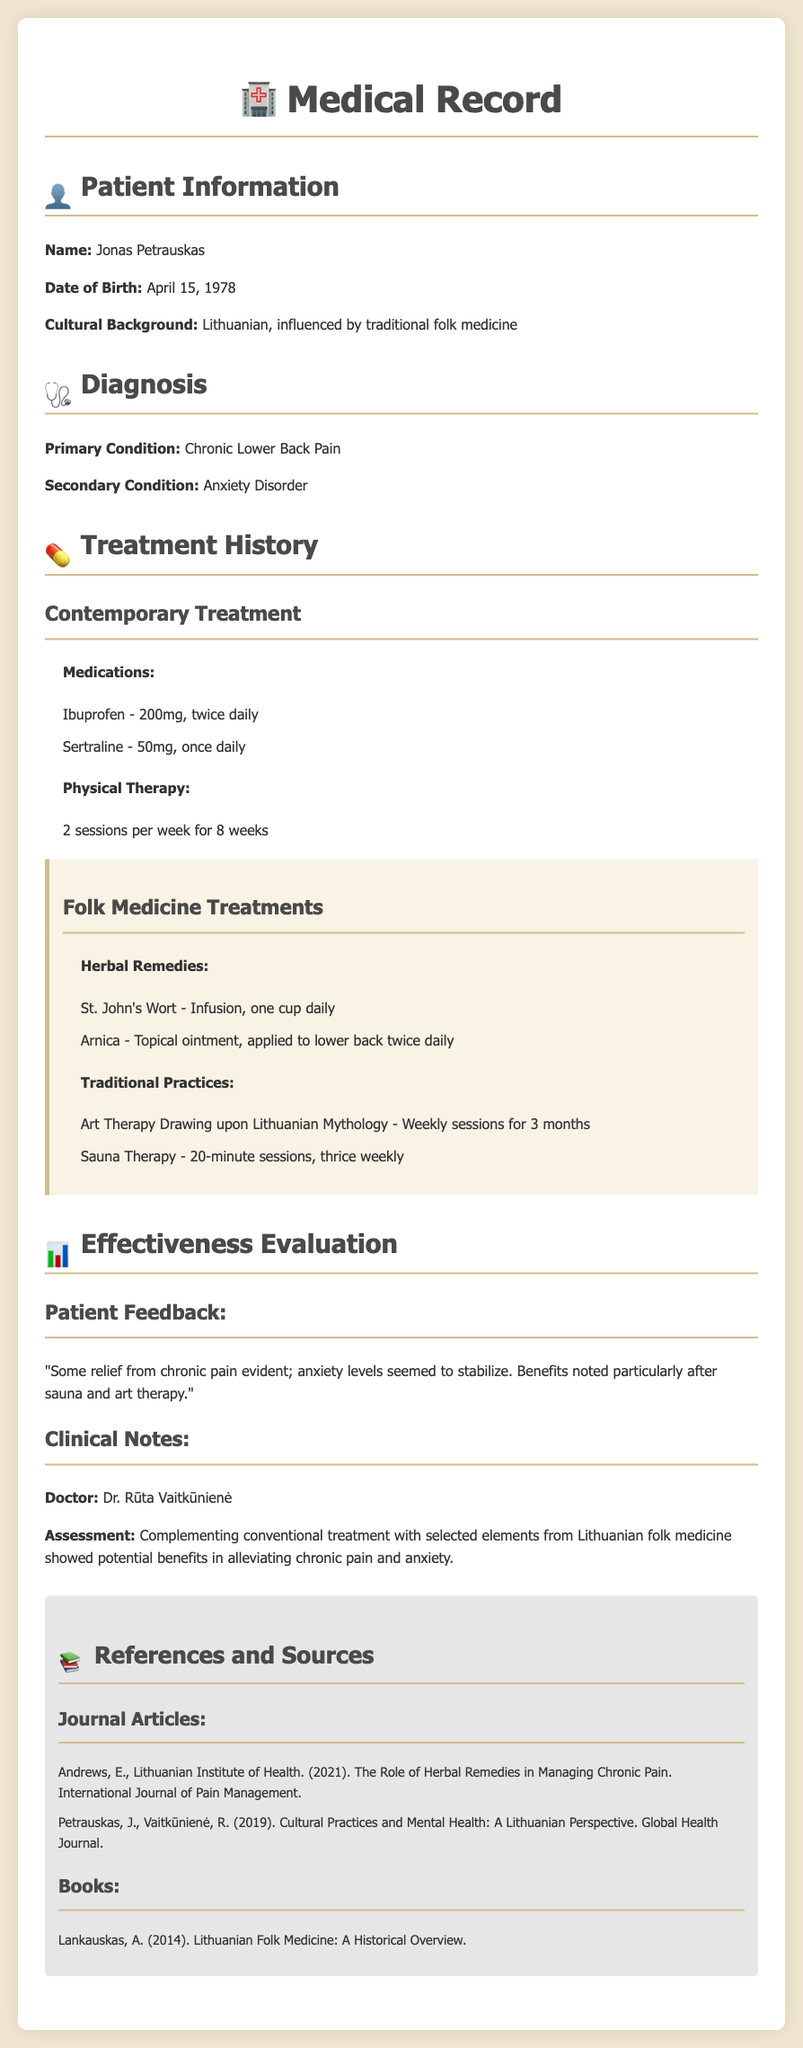What is the patient's primary condition? The primary condition is listed in the diagnosis section as Chronic Lower Back Pain.
Answer: Chronic Lower Back Pain Who is the treating doctor? The treating doctor's name is found in the clinical notes section as Dr. Rūta Vaitkūnienė.
Answer: Dr. Rūta Vaitkūnienė What herbal remedy is taken as an infusion? This information is in the folk medicine treatments section under herbal remedies, stating that St. John's Wort is taken as an infusion.
Answer: St. John's Wort How often does the patient attend physical therapy sessions? The frequency of physical therapy sessions is detailed in the treatment history section as 2 sessions per week.
Answer: 2 sessions per week What is the patient's cultural background? The patient's cultural background is mentioned in the patient information section, which states it as Lithuanian, influenced by traditional folk medicine.
Answer: Lithuanian, influenced by traditional folk medicine What was the patient feedback regarding the effectiveness of therapy? The patient feedback is found in the effectiveness evaluation section describing relief from chronic pain and stabilization of anxiety levels.
Answer: Some relief from chronic pain evident; anxiety levels seemed to stabilize How often are sauna therapy sessions conducted? The frequency of sauna therapy sessions is provided in the folk medicine treatments section as thrice weekly.
Answer: Thrice weekly What is the dose of Ibuprofen prescribed? The dose of Ibuprofen is outlined in the contemporary treatment section, indicating it as 200mg, twice daily.
Answer: 200mg, twice daily What type of therapy sessions does the patient undergo related to Lithuanian mythology? The document specifies that Art Therapy Drawing upon Lithuanian Mythology is part of the folk medicine treatments under traditional practices.
Answer: Art Therapy Drawing upon Lithuanian Mythology 